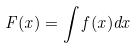<formula> <loc_0><loc_0><loc_500><loc_500>F ( x ) = \int f ( x ) d x</formula> 